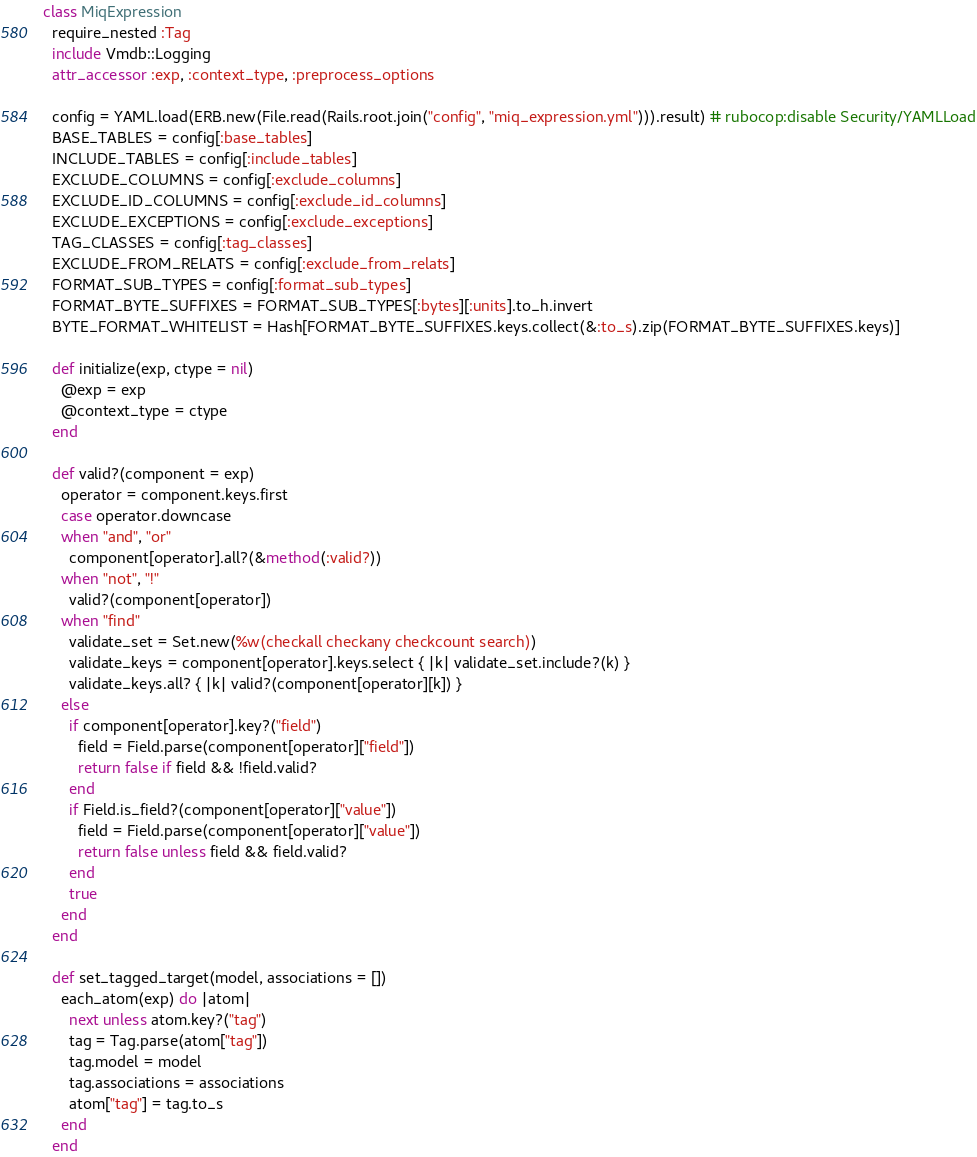<code> <loc_0><loc_0><loc_500><loc_500><_Ruby_>class MiqExpression
  require_nested :Tag
  include Vmdb::Logging
  attr_accessor :exp, :context_type, :preprocess_options

  config = YAML.load(ERB.new(File.read(Rails.root.join("config", "miq_expression.yml"))).result) # rubocop:disable Security/YAMLLoad
  BASE_TABLES = config[:base_tables]
  INCLUDE_TABLES = config[:include_tables]
  EXCLUDE_COLUMNS = config[:exclude_columns]
  EXCLUDE_ID_COLUMNS = config[:exclude_id_columns]
  EXCLUDE_EXCEPTIONS = config[:exclude_exceptions]
  TAG_CLASSES = config[:tag_classes]
  EXCLUDE_FROM_RELATS = config[:exclude_from_relats]
  FORMAT_SUB_TYPES = config[:format_sub_types]
  FORMAT_BYTE_SUFFIXES = FORMAT_SUB_TYPES[:bytes][:units].to_h.invert
  BYTE_FORMAT_WHITELIST = Hash[FORMAT_BYTE_SUFFIXES.keys.collect(&:to_s).zip(FORMAT_BYTE_SUFFIXES.keys)]

  def initialize(exp, ctype = nil)
    @exp = exp
    @context_type = ctype
  end

  def valid?(component = exp)
    operator = component.keys.first
    case operator.downcase
    when "and", "or"
      component[operator].all?(&method(:valid?))
    when "not", "!"
      valid?(component[operator])
    when "find"
      validate_set = Set.new(%w(checkall checkany checkcount search))
      validate_keys = component[operator].keys.select { |k| validate_set.include?(k) }
      validate_keys.all? { |k| valid?(component[operator][k]) }
    else
      if component[operator].key?("field")
        field = Field.parse(component[operator]["field"])
        return false if field && !field.valid?
      end
      if Field.is_field?(component[operator]["value"])
        field = Field.parse(component[operator]["value"])
        return false unless field && field.valid?
      end
      true
    end
  end

  def set_tagged_target(model, associations = [])
    each_atom(exp) do |atom|
      next unless atom.key?("tag")
      tag = Tag.parse(atom["tag"])
      tag.model = model
      tag.associations = associations
      atom["tag"] = tag.to_s
    end
  end
</code> 